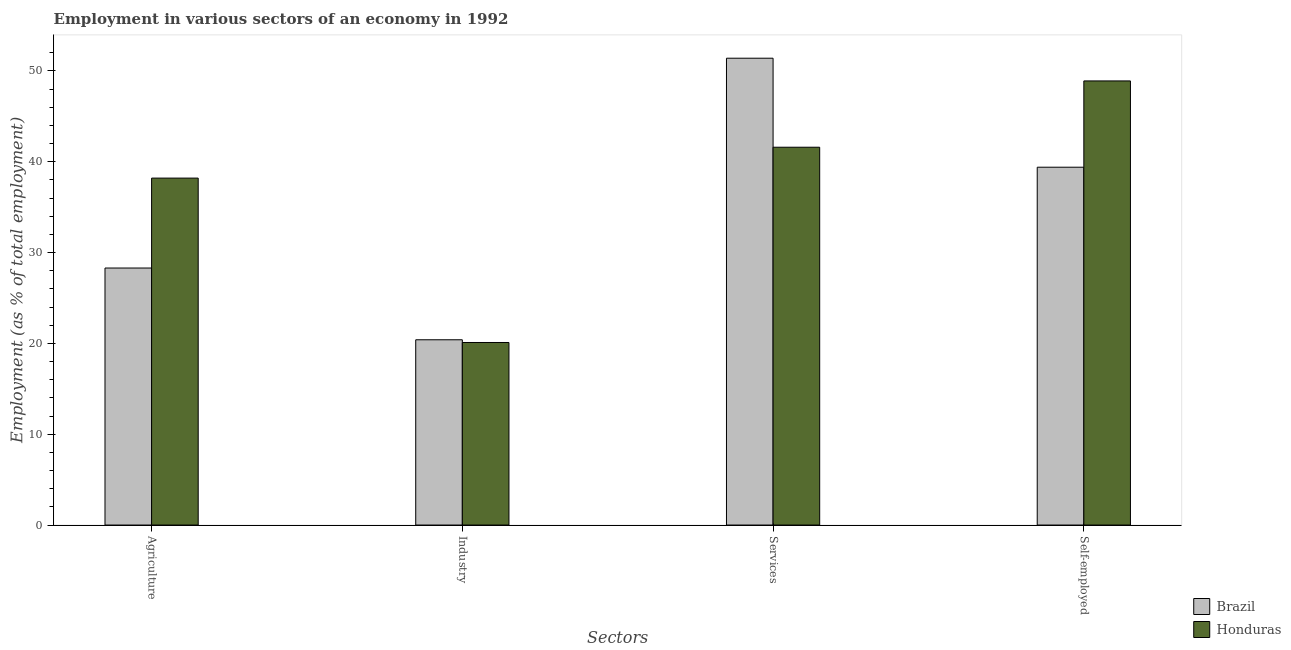How many different coloured bars are there?
Provide a succinct answer. 2. Are the number of bars per tick equal to the number of legend labels?
Keep it short and to the point. Yes. What is the label of the 4th group of bars from the left?
Your answer should be very brief. Self-employed. What is the percentage of workers in services in Brazil?
Offer a very short reply. 51.4. Across all countries, what is the maximum percentage of workers in industry?
Ensure brevity in your answer.  20.4. Across all countries, what is the minimum percentage of workers in services?
Provide a short and direct response. 41.6. In which country was the percentage of workers in industry minimum?
Give a very brief answer. Honduras. What is the total percentage of workers in agriculture in the graph?
Make the answer very short. 66.5. What is the difference between the percentage of workers in agriculture in Honduras and that in Brazil?
Provide a short and direct response. 9.9. What is the difference between the percentage of self employed workers in Brazil and the percentage of workers in industry in Honduras?
Give a very brief answer. 19.3. What is the average percentage of self employed workers per country?
Your answer should be very brief. 44.15. What is the difference between the percentage of workers in industry and percentage of self employed workers in Brazil?
Make the answer very short. -19. What is the ratio of the percentage of self employed workers in Honduras to that in Brazil?
Make the answer very short. 1.24. What is the difference between the highest and the second highest percentage of workers in industry?
Offer a very short reply. 0.3. In how many countries, is the percentage of self employed workers greater than the average percentage of self employed workers taken over all countries?
Provide a short and direct response. 1. Is the sum of the percentage of self employed workers in Brazil and Honduras greater than the maximum percentage of workers in agriculture across all countries?
Ensure brevity in your answer.  Yes. What does the 2nd bar from the right in Agriculture represents?
Ensure brevity in your answer.  Brazil. Is it the case that in every country, the sum of the percentage of workers in agriculture and percentage of workers in industry is greater than the percentage of workers in services?
Provide a short and direct response. No. How many bars are there?
Provide a short and direct response. 8. Are all the bars in the graph horizontal?
Your answer should be compact. No. How many countries are there in the graph?
Make the answer very short. 2. What is the difference between two consecutive major ticks on the Y-axis?
Your answer should be very brief. 10. Are the values on the major ticks of Y-axis written in scientific E-notation?
Make the answer very short. No. Where does the legend appear in the graph?
Offer a very short reply. Bottom right. How many legend labels are there?
Provide a short and direct response. 2. How are the legend labels stacked?
Ensure brevity in your answer.  Vertical. What is the title of the graph?
Your answer should be compact. Employment in various sectors of an economy in 1992. What is the label or title of the X-axis?
Ensure brevity in your answer.  Sectors. What is the label or title of the Y-axis?
Offer a very short reply. Employment (as % of total employment). What is the Employment (as % of total employment) of Brazil in Agriculture?
Offer a very short reply. 28.3. What is the Employment (as % of total employment) in Honduras in Agriculture?
Provide a succinct answer. 38.2. What is the Employment (as % of total employment) in Brazil in Industry?
Offer a very short reply. 20.4. What is the Employment (as % of total employment) in Honduras in Industry?
Provide a succinct answer. 20.1. What is the Employment (as % of total employment) in Brazil in Services?
Your response must be concise. 51.4. What is the Employment (as % of total employment) in Honduras in Services?
Your response must be concise. 41.6. What is the Employment (as % of total employment) in Brazil in Self-employed?
Make the answer very short. 39.4. What is the Employment (as % of total employment) in Honduras in Self-employed?
Make the answer very short. 48.9. Across all Sectors, what is the maximum Employment (as % of total employment) of Brazil?
Your answer should be very brief. 51.4. Across all Sectors, what is the maximum Employment (as % of total employment) in Honduras?
Make the answer very short. 48.9. Across all Sectors, what is the minimum Employment (as % of total employment) of Brazil?
Ensure brevity in your answer.  20.4. Across all Sectors, what is the minimum Employment (as % of total employment) of Honduras?
Your answer should be compact. 20.1. What is the total Employment (as % of total employment) of Brazil in the graph?
Your answer should be very brief. 139.5. What is the total Employment (as % of total employment) of Honduras in the graph?
Ensure brevity in your answer.  148.8. What is the difference between the Employment (as % of total employment) in Brazil in Agriculture and that in Industry?
Provide a short and direct response. 7.9. What is the difference between the Employment (as % of total employment) of Brazil in Agriculture and that in Services?
Make the answer very short. -23.1. What is the difference between the Employment (as % of total employment) of Brazil in Industry and that in Services?
Give a very brief answer. -31. What is the difference between the Employment (as % of total employment) of Honduras in Industry and that in Services?
Offer a very short reply. -21.5. What is the difference between the Employment (as % of total employment) in Honduras in Industry and that in Self-employed?
Make the answer very short. -28.8. What is the difference between the Employment (as % of total employment) of Brazil in Services and that in Self-employed?
Offer a terse response. 12. What is the difference between the Employment (as % of total employment) of Brazil in Agriculture and the Employment (as % of total employment) of Honduras in Industry?
Keep it short and to the point. 8.2. What is the difference between the Employment (as % of total employment) of Brazil in Agriculture and the Employment (as % of total employment) of Honduras in Self-employed?
Your answer should be very brief. -20.6. What is the difference between the Employment (as % of total employment) of Brazil in Industry and the Employment (as % of total employment) of Honduras in Services?
Make the answer very short. -21.2. What is the difference between the Employment (as % of total employment) in Brazil in Industry and the Employment (as % of total employment) in Honduras in Self-employed?
Your response must be concise. -28.5. What is the average Employment (as % of total employment) of Brazil per Sectors?
Your answer should be compact. 34.88. What is the average Employment (as % of total employment) in Honduras per Sectors?
Make the answer very short. 37.2. What is the difference between the Employment (as % of total employment) in Brazil and Employment (as % of total employment) in Honduras in Services?
Keep it short and to the point. 9.8. What is the difference between the Employment (as % of total employment) in Brazil and Employment (as % of total employment) in Honduras in Self-employed?
Give a very brief answer. -9.5. What is the ratio of the Employment (as % of total employment) of Brazil in Agriculture to that in Industry?
Keep it short and to the point. 1.39. What is the ratio of the Employment (as % of total employment) of Honduras in Agriculture to that in Industry?
Offer a very short reply. 1.9. What is the ratio of the Employment (as % of total employment) of Brazil in Agriculture to that in Services?
Provide a short and direct response. 0.55. What is the ratio of the Employment (as % of total employment) in Honduras in Agriculture to that in Services?
Provide a short and direct response. 0.92. What is the ratio of the Employment (as % of total employment) in Brazil in Agriculture to that in Self-employed?
Your response must be concise. 0.72. What is the ratio of the Employment (as % of total employment) of Honduras in Agriculture to that in Self-employed?
Your answer should be very brief. 0.78. What is the ratio of the Employment (as % of total employment) in Brazil in Industry to that in Services?
Offer a very short reply. 0.4. What is the ratio of the Employment (as % of total employment) in Honduras in Industry to that in Services?
Make the answer very short. 0.48. What is the ratio of the Employment (as % of total employment) in Brazil in Industry to that in Self-employed?
Keep it short and to the point. 0.52. What is the ratio of the Employment (as % of total employment) in Honduras in Industry to that in Self-employed?
Give a very brief answer. 0.41. What is the ratio of the Employment (as % of total employment) of Brazil in Services to that in Self-employed?
Your response must be concise. 1.3. What is the ratio of the Employment (as % of total employment) in Honduras in Services to that in Self-employed?
Keep it short and to the point. 0.85. What is the difference between the highest and the lowest Employment (as % of total employment) of Brazil?
Your response must be concise. 31. What is the difference between the highest and the lowest Employment (as % of total employment) in Honduras?
Provide a short and direct response. 28.8. 